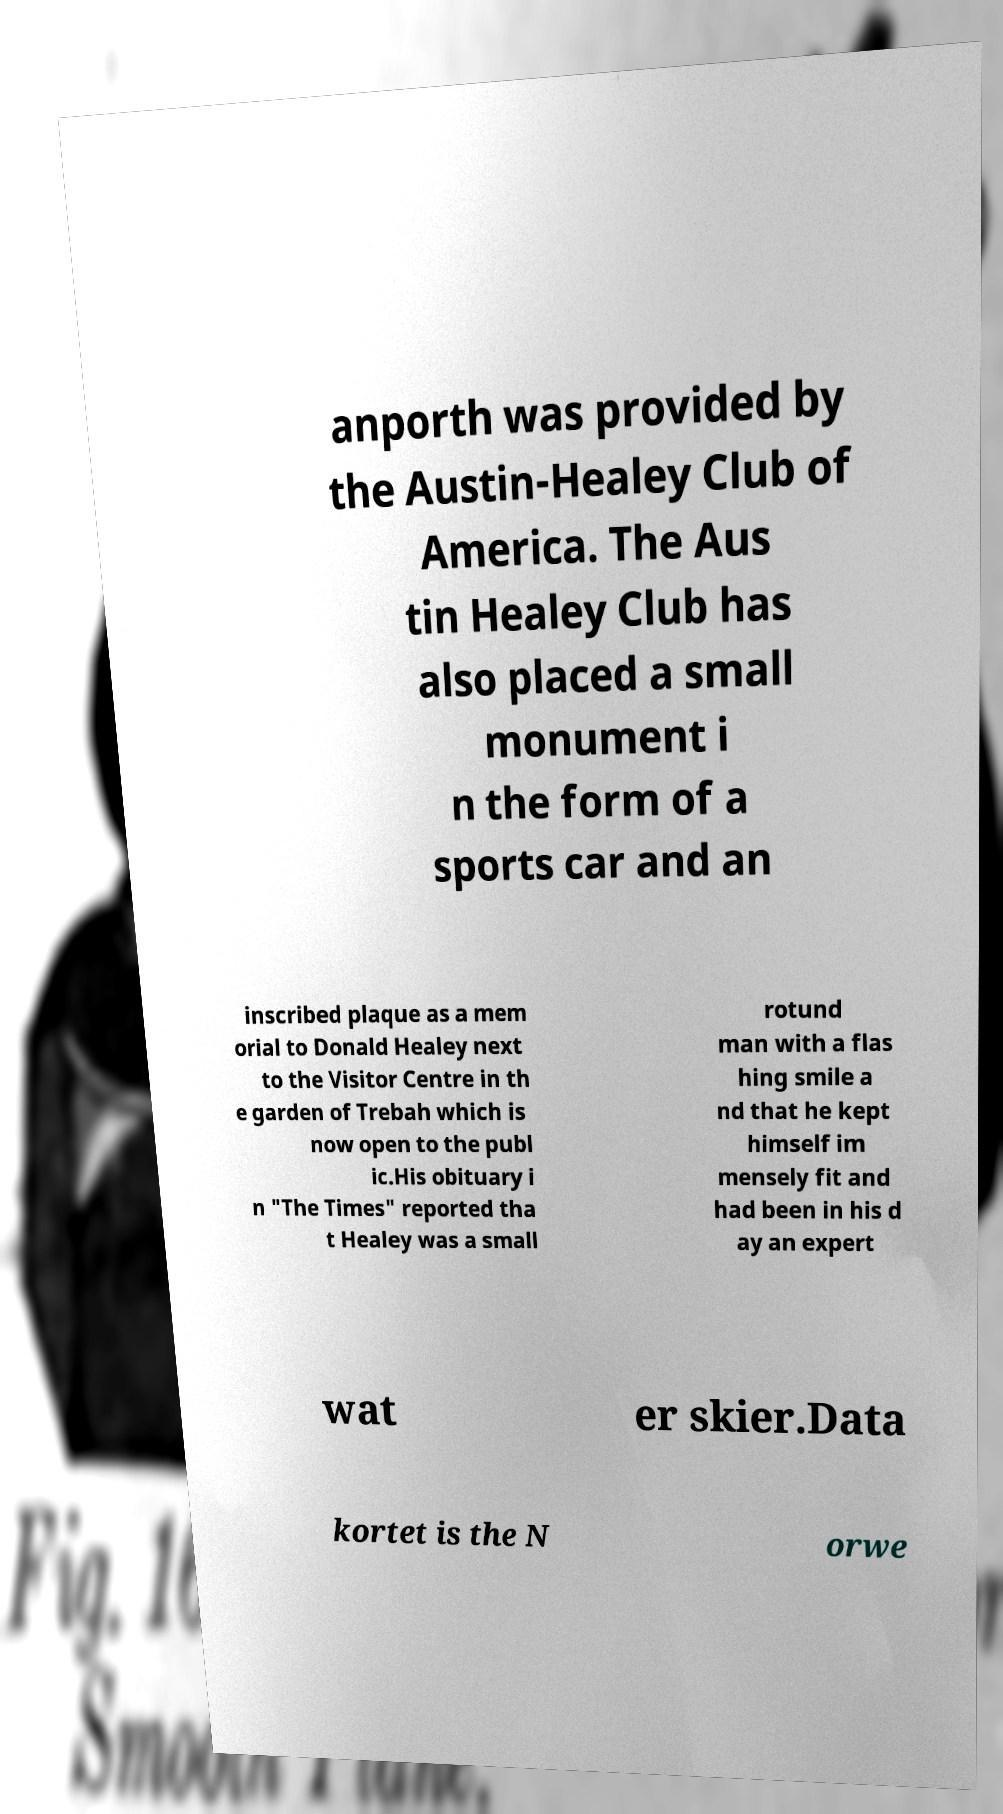What messages or text are displayed in this image? I need them in a readable, typed format. anporth was provided by the Austin-Healey Club of America. The Aus tin Healey Club has also placed a small monument i n the form of a sports car and an inscribed plaque as a mem orial to Donald Healey next to the Visitor Centre in th e garden of Trebah which is now open to the publ ic.His obituary i n "The Times" reported tha t Healey was a small rotund man with a flas hing smile a nd that he kept himself im mensely fit and had been in his d ay an expert wat er skier.Data kortet is the N orwe 